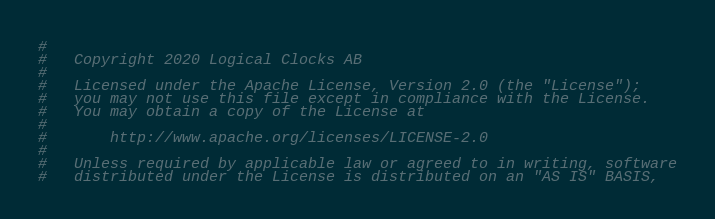Convert code to text. <code><loc_0><loc_0><loc_500><loc_500><_Python_>#
#   Copyright 2020 Logical Clocks AB
#
#   Licensed under the Apache License, Version 2.0 (the "License");
#   you may not use this file except in compliance with the License.
#   You may obtain a copy of the License at
#
#       http://www.apache.org/licenses/LICENSE-2.0
#
#   Unless required by applicable law or agreed to in writing, software
#   distributed under the License is distributed on an "AS IS" BASIS,</code> 